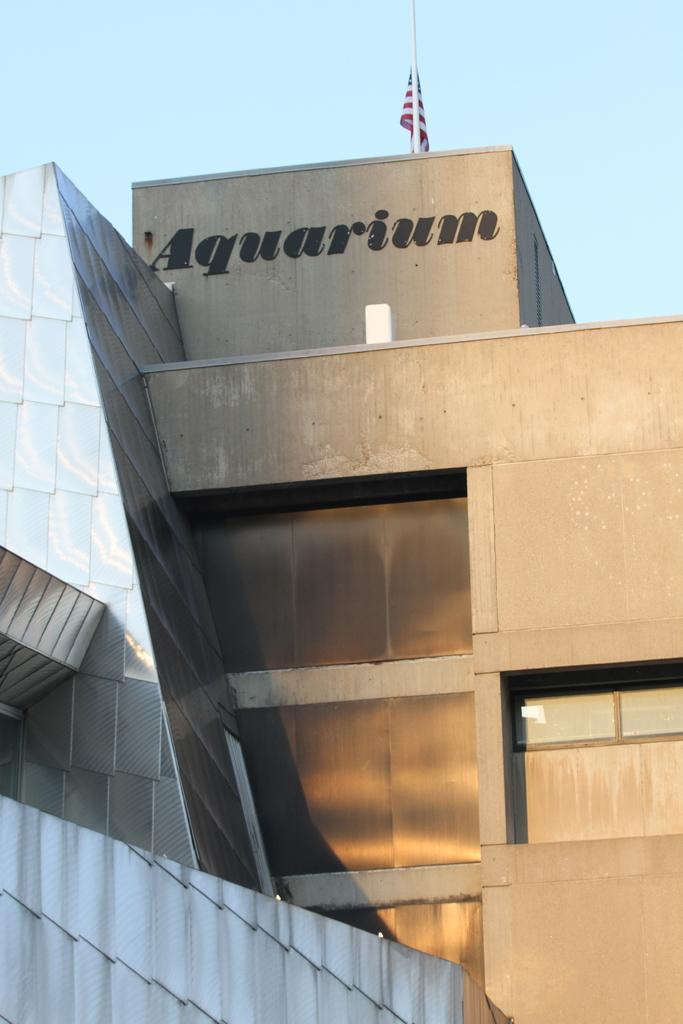<image>
Relay a brief, clear account of the picture shown. A brown stone building with the title Aquarium on the side. 